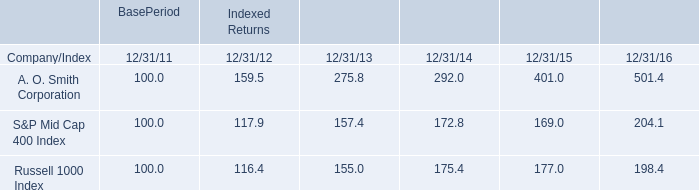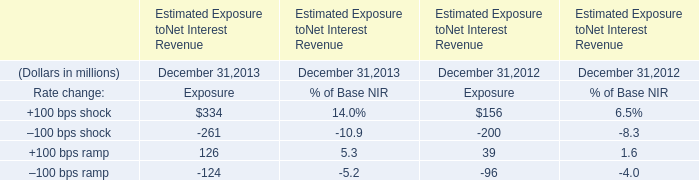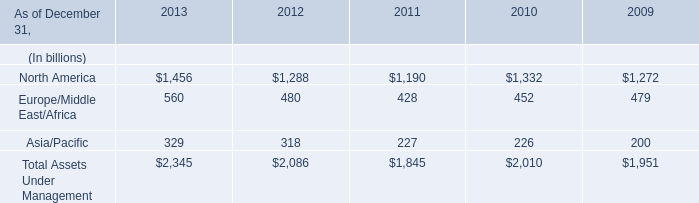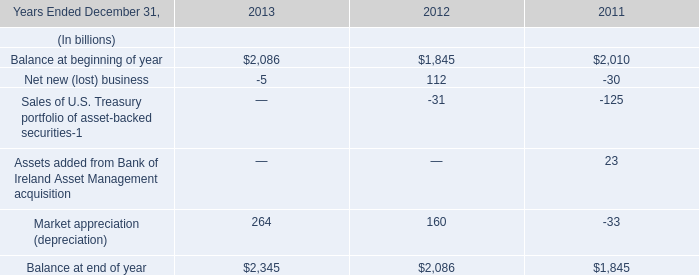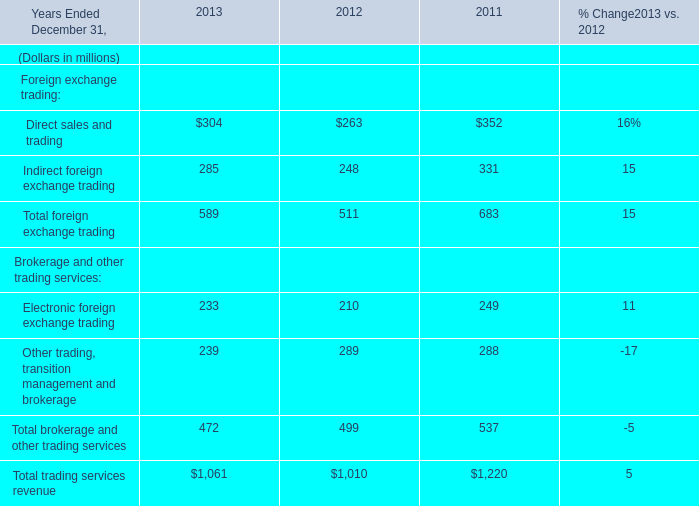What's the increasing rate of Balance at beginning of year in 2013 Ended December 31,2013? 
Computations: ((2086 - 1845) / 1845)
Answer: 0.13062. 